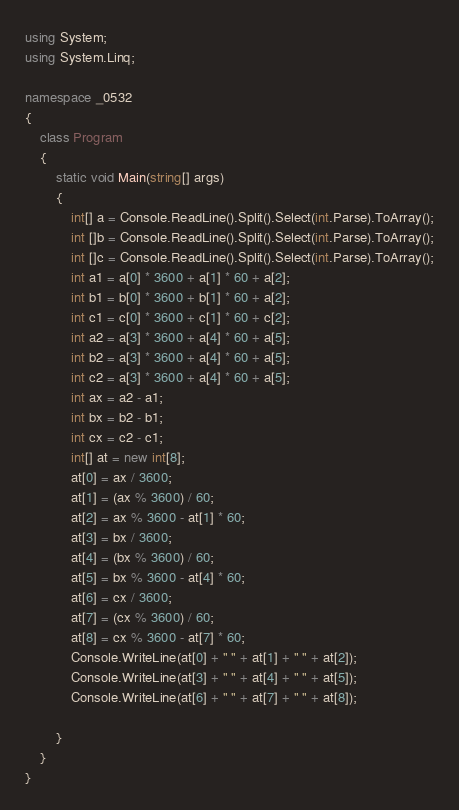Convert code to text. <code><loc_0><loc_0><loc_500><loc_500><_C#_>using System;
using System.Linq;

namespace _0532
{
    class Program
    {
        static void Main(string[] args)
        {
            int[] a = Console.ReadLine().Split().Select(int.Parse).ToArray();
            int []b = Console.ReadLine().Split().Select(int.Parse).ToArray();
            int []c = Console.ReadLine().Split().Select(int.Parse).ToArray();
            int a1 = a[0] * 3600 + a[1] * 60 + a[2];
            int b1 = b[0] * 3600 + b[1] * 60 + a[2];
            int c1 = c[0] * 3600 + c[1] * 60 + c[2];
            int a2 = a[3] * 3600 + a[4] * 60 + a[5];
            int b2 = a[3] * 3600 + a[4] * 60 + a[5];
            int c2 = a[3] * 3600 + a[4] * 60 + a[5];
            int ax = a2 - a1;
            int bx = b2 - b1;
            int cx = c2 - c1;
            int[] at = new int[8];
            at[0] = ax / 3600;
            at[1] = (ax % 3600) / 60;
            at[2] = ax % 3600 - at[1] * 60;
            at[3] = bx / 3600;
            at[4] = (bx % 3600) / 60;
            at[5] = bx % 3600 - at[4] * 60;
            at[6] = cx / 3600;
            at[7] = (cx % 3600) / 60;
            at[8] = cx % 3600 - at[7] * 60;
            Console.WriteLine(at[0] + " " + at[1] + " " + at[2]);
            Console.WriteLine(at[3] + " " + at[4] + " " + at[5]);
            Console.WriteLine(at[6] + " " + at[7] + " " + at[8]);

        }
    }
}</code> 